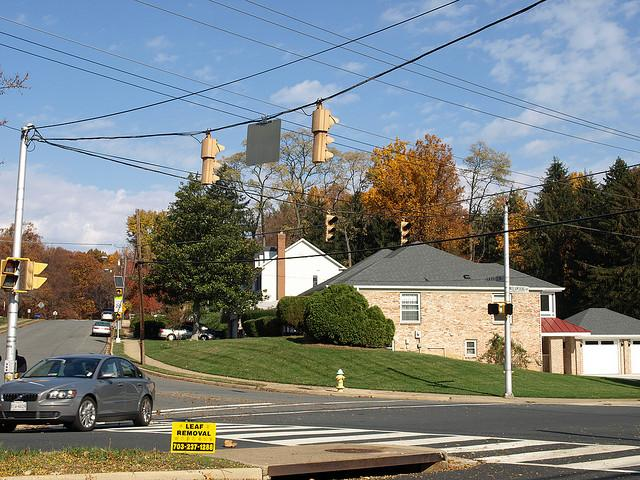What kind of trash can the company advertising on yellow sign help with? leaves 